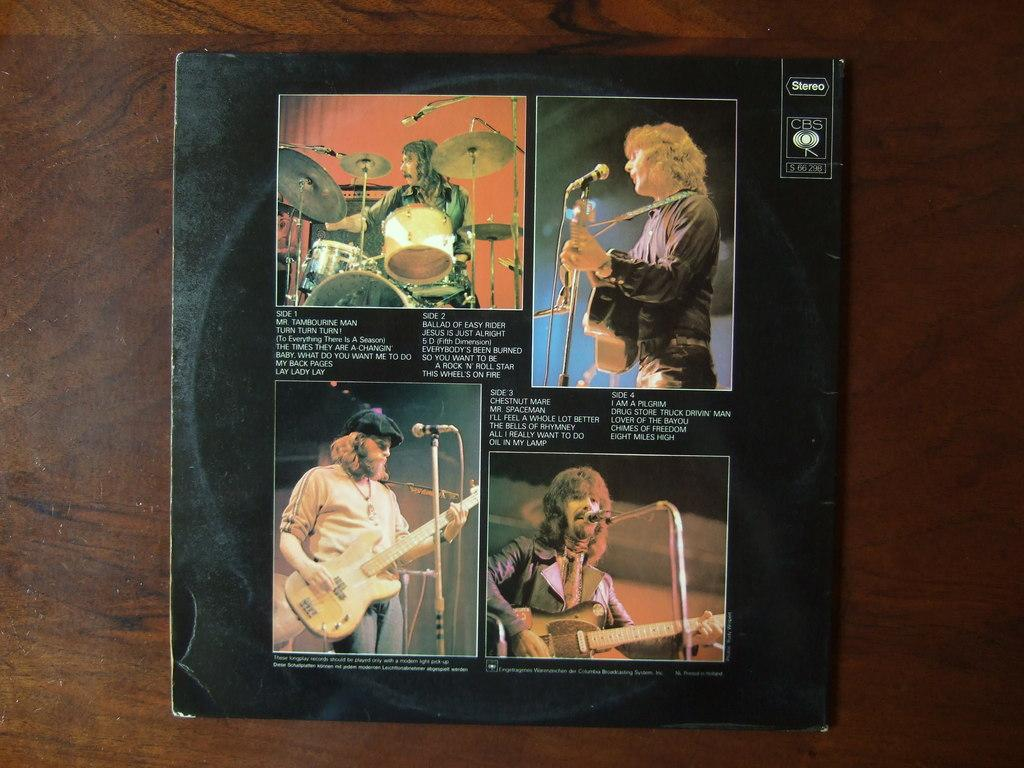<image>
Share a concise interpretation of the image provided. Album showing men performin on stage and the word "Stereo" on the top right. 